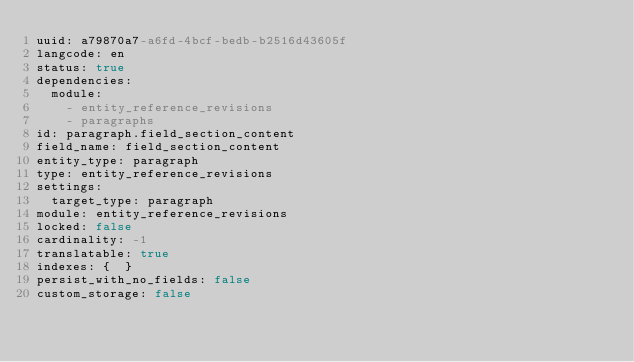Convert code to text. <code><loc_0><loc_0><loc_500><loc_500><_YAML_>uuid: a79870a7-a6fd-4bcf-bedb-b2516d43605f
langcode: en
status: true
dependencies:
  module:
    - entity_reference_revisions
    - paragraphs
id: paragraph.field_section_content
field_name: field_section_content
entity_type: paragraph
type: entity_reference_revisions
settings:
  target_type: paragraph
module: entity_reference_revisions
locked: false
cardinality: -1
translatable: true
indexes: {  }
persist_with_no_fields: false
custom_storage: false
</code> 